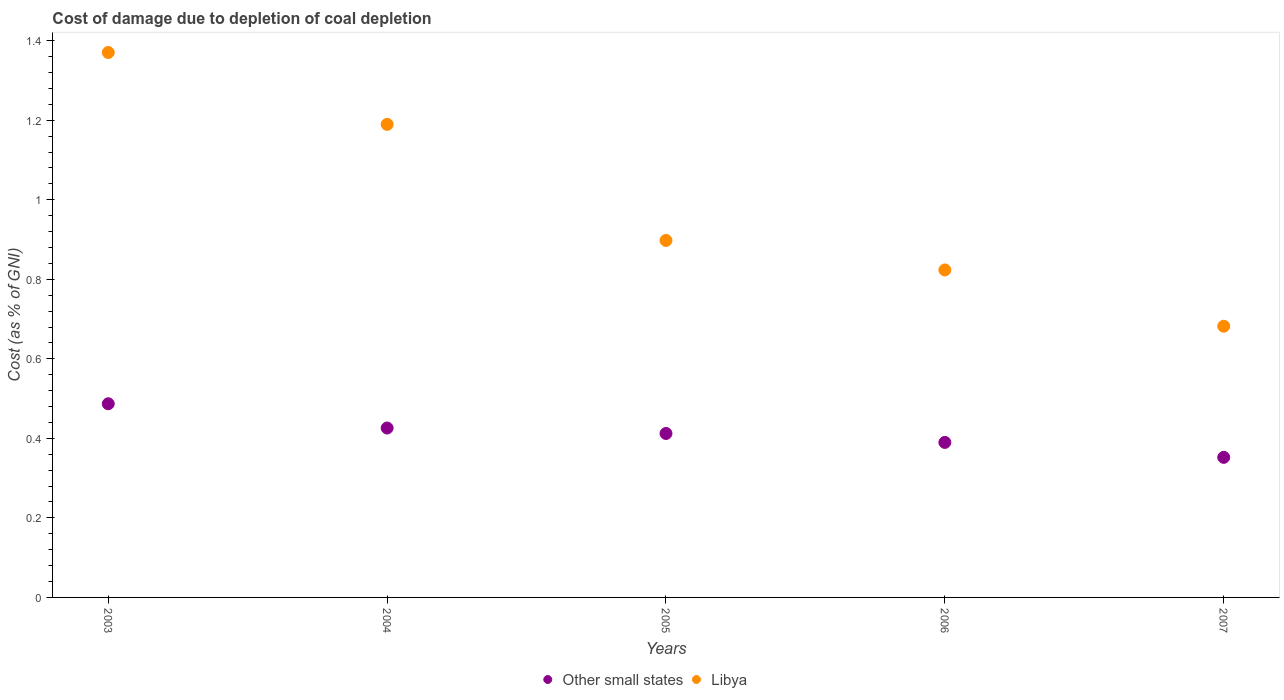How many different coloured dotlines are there?
Your answer should be very brief. 2. What is the cost of damage caused due to coal depletion in Other small states in 2005?
Give a very brief answer. 0.41. Across all years, what is the maximum cost of damage caused due to coal depletion in Libya?
Offer a very short reply. 1.37. Across all years, what is the minimum cost of damage caused due to coal depletion in Other small states?
Keep it short and to the point. 0.35. In which year was the cost of damage caused due to coal depletion in Other small states minimum?
Your answer should be very brief. 2007. What is the total cost of damage caused due to coal depletion in Other small states in the graph?
Offer a very short reply. 2.07. What is the difference between the cost of damage caused due to coal depletion in Other small states in 2006 and that in 2007?
Your answer should be compact. 0.04. What is the difference between the cost of damage caused due to coal depletion in Libya in 2005 and the cost of damage caused due to coal depletion in Other small states in 2007?
Offer a terse response. 0.55. What is the average cost of damage caused due to coal depletion in Other small states per year?
Your answer should be very brief. 0.41. In the year 2007, what is the difference between the cost of damage caused due to coal depletion in Libya and cost of damage caused due to coal depletion in Other small states?
Keep it short and to the point. 0.33. What is the ratio of the cost of damage caused due to coal depletion in Libya in 2003 to that in 2006?
Ensure brevity in your answer.  1.66. Is the cost of damage caused due to coal depletion in Libya in 2005 less than that in 2007?
Provide a succinct answer. No. What is the difference between the highest and the second highest cost of damage caused due to coal depletion in Libya?
Keep it short and to the point. 0.18. What is the difference between the highest and the lowest cost of damage caused due to coal depletion in Other small states?
Ensure brevity in your answer.  0.13. In how many years, is the cost of damage caused due to coal depletion in Libya greater than the average cost of damage caused due to coal depletion in Libya taken over all years?
Your answer should be very brief. 2. Is the sum of the cost of damage caused due to coal depletion in Other small states in 2004 and 2007 greater than the maximum cost of damage caused due to coal depletion in Libya across all years?
Make the answer very short. No. Does the cost of damage caused due to coal depletion in Other small states monotonically increase over the years?
Keep it short and to the point. No. Is the cost of damage caused due to coal depletion in Other small states strictly greater than the cost of damage caused due to coal depletion in Libya over the years?
Offer a terse response. No. Does the graph contain grids?
Ensure brevity in your answer.  No. Where does the legend appear in the graph?
Ensure brevity in your answer.  Bottom center. How many legend labels are there?
Your answer should be very brief. 2. What is the title of the graph?
Make the answer very short. Cost of damage due to depletion of coal depletion. What is the label or title of the Y-axis?
Provide a succinct answer. Cost (as % of GNI). What is the Cost (as % of GNI) of Other small states in 2003?
Your answer should be compact. 0.49. What is the Cost (as % of GNI) of Libya in 2003?
Provide a succinct answer. 1.37. What is the Cost (as % of GNI) in Other small states in 2004?
Ensure brevity in your answer.  0.43. What is the Cost (as % of GNI) of Libya in 2004?
Your answer should be very brief. 1.19. What is the Cost (as % of GNI) of Other small states in 2005?
Ensure brevity in your answer.  0.41. What is the Cost (as % of GNI) of Libya in 2005?
Give a very brief answer. 0.9. What is the Cost (as % of GNI) of Other small states in 2006?
Give a very brief answer. 0.39. What is the Cost (as % of GNI) in Libya in 2006?
Offer a very short reply. 0.82. What is the Cost (as % of GNI) of Other small states in 2007?
Ensure brevity in your answer.  0.35. What is the Cost (as % of GNI) in Libya in 2007?
Make the answer very short. 0.68. Across all years, what is the maximum Cost (as % of GNI) of Other small states?
Provide a succinct answer. 0.49. Across all years, what is the maximum Cost (as % of GNI) of Libya?
Provide a short and direct response. 1.37. Across all years, what is the minimum Cost (as % of GNI) of Other small states?
Make the answer very short. 0.35. Across all years, what is the minimum Cost (as % of GNI) of Libya?
Your response must be concise. 0.68. What is the total Cost (as % of GNI) of Other small states in the graph?
Make the answer very short. 2.07. What is the total Cost (as % of GNI) of Libya in the graph?
Provide a short and direct response. 4.96. What is the difference between the Cost (as % of GNI) in Other small states in 2003 and that in 2004?
Your answer should be very brief. 0.06. What is the difference between the Cost (as % of GNI) of Libya in 2003 and that in 2004?
Offer a very short reply. 0.18. What is the difference between the Cost (as % of GNI) in Other small states in 2003 and that in 2005?
Offer a very short reply. 0.07. What is the difference between the Cost (as % of GNI) in Libya in 2003 and that in 2005?
Give a very brief answer. 0.47. What is the difference between the Cost (as % of GNI) in Other small states in 2003 and that in 2006?
Give a very brief answer. 0.1. What is the difference between the Cost (as % of GNI) of Libya in 2003 and that in 2006?
Ensure brevity in your answer.  0.55. What is the difference between the Cost (as % of GNI) of Other small states in 2003 and that in 2007?
Offer a very short reply. 0.13. What is the difference between the Cost (as % of GNI) in Libya in 2003 and that in 2007?
Make the answer very short. 0.69. What is the difference between the Cost (as % of GNI) in Other small states in 2004 and that in 2005?
Provide a succinct answer. 0.01. What is the difference between the Cost (as % of GNI) in Libya in 2004 and that in 2005?
Your answer should be compact. 0.29. What is the difference between the Cost (as % of GNI) in Other small states in 2004 and that in 2006?
Ensure brevity in your answer.  0.04. What is the difference between the Cost (as % of GNI) in Libya in 2004 and that in 2006?
Make the answer very short. 0.37. What is the difference between the Cost (as % of GNI) in Other small states in 2004 and that in 2007?
Offer a very short reply. 0.07. What is the difference between the Cost (as % of GNI) of Libya in 2004 and that in 2007?
Give a very brief answer. 0.51. What is the difference between the Cost (as % of GNI) of Other small states in 2005 and that in 2006?
Give a very brief answer. 0.02. What is the difference between the Cost (as % of GNI) in Libya in 2005 and that in 2006?
Keep it short and to the point. 0.07. What is the difference between the Cost (as % of GNI) in Libya in 2005 and that in 2007?
Give a very brief answer. 0.22. What is the difference between the Cost (as % of GNI) in Other small states in 2006 and that in 2007?
Offer a terse response. 0.04. What is the difference between the Cost (as % of GNI) in Libya in 2006 and that in 2007?
Give a very brief answer. 0.14. What is the difference between the Cost (as % of GNI) of Other small states in 2003 and the Cost (as % of GNI) of Libya in 2004?
Provide a short and direct response. -0.7. What is the difference between the Cost (as % of GNI) of Other small states in 2003 and the Cost (as % of GNI) of Libya in 2005?
Offer a very short reply. -0.41. What is the difference between the Cost (as % of GNI) in Other small states in 2003 and the Cost (as % of GNI) in Libya in 2006?
Your response must be concise. -0.34. What is the difference between the Cost (as % of GNI) in Other small states in 2003 and the Cost (as % of GNI) in Libya in 2007?
Keep it short and to the point. -0.2. What is the difference between the Cost (as % of GNI) of Other small states in 2004 and the Cost (as % of GNI) of Libya in 2005?
Make the answer very short. -0.47. What is the difference between the Cost (as % of GNI) of Other small states in 2004 and the Cost (as % of GNI) of Libya in 2006?
Your response must be concise. -0.4. What is the difference between the Cost (as % of GNI) of Other small states in 2004 and the Cost (as % of GNI) of Libya in 2007?
Provide a succinct answer. -0.26. What is the difference between the Cost (as % of GNI) in Other small states in 2005 and the Cost (as % of GNI) in Libya in 2006?
Your answer should be very brief. -0.41. What is the difference between the Cost (as % of GNI) of Other small states in 2005 and the Cost (as % of GNI) of Libya in 2007?
Your answer should be very brief. -0.27. What is the difference between the Cost (as % of GNI) in Other small states in 2006 and the Cost (as % of GNI) in Libya in 2007?
Make the answer very short. -0.29. What is the average Cost (as % of GNI) in Other small states per year?
Your answer should be compact. 0.41. In the year 2003, what is the difference between the Cost (as % of GNI) of Other small states and Cost (as % of GNI) of Libya?
Your answer should be compact. -0.88. In the year 2004, what is the difference between the Cost (as % of GNI) of Other small states and Cost (as % of GNI) of Libya?
Give a very brief answer. -0.76. In the year 2005, what is the difference between the Cost (as % of GNI) of Other small states and Cost (as % of GNI) of Libya?
Provide a short and direct response. -0.49. In the year 2006, what is the difference between the Cost (as % of GNI) of Other small states and Cost (as % of GNI) of Libya?
Make the answer very short. -0.43. In the year 2007, what is the difference between the Cost (as % of GNI) in Other small states and Cost (as % of GNI) in Libya?
Give a very brief answer. -0.33. What is the ratio of the Cost (as % of GNI) of Other small states in 2003 to that in 2004?
Your answer should be compact. 1.14. What is the ratio of the Cost (as % of GNI) of Libya in 2003 to that in 2004?
Give a very brief answer. 1.15. What is the ratio of the Cost (as % of GNI) of Other small states in 2003 to that in 2005?
Make the answer very short. 1.18. What is the ratio of the Cost (as % of GNI) of Libya in 2003 to that in 2005?
Your answer should be very brief. 1.53. What is the ratio of the Cost (as % of GNI) in Other small states in 2003 to that in 2006?
Your response must be concise. 1.25. What is the ratio of the Cost (as % of GNI) in Libya in 2003 to that in 2006?
Your answer should be very brief. 1.66. What is the ratio of the Cost (as % of GNI) in Other small states in 2003 to that in 2007?
Your response must be concise. 1.38. What is the ratio of the Cost (as % of GNI) in Libya in 2003 to that in 2007?
Your answer should be very brief. 2.01. What is the ratio of the Cost (as % of GNI) of Other small states in 2004 to that in 2005?
Offer a very short reply. 1.03. What is the ratio of the Cost (as % of GNI) of Libya in 2004 to that in 2005?
Give a very brief answer. 1.33. What is the ratio of the Cost (as % of GNI) of Other small states in 2004 to that in 2006?
Your answer should be very brief. 1.09. What is the ratio of the Cost (as % of GNI) in Libya in 2004 to that in 2006?
Provide a short and direct response. 1.44. What is the ratio of the Cost (as % of GNI) in Other small states in 2004 to that in 2007?
Make the answer very short. 1.21. What is the ratio of the Cost (as % of GNI) in Libya in 2004 to that in 2007?
Provide a short and direct response. 1.74. What is the ratio of the Cost (as % of GNI) in Other small states in 2005 to that in 2006?
Make the answer very short. 1.06. What is the ratio of the Cost (as % of GNI) of Libya in 2005 to that in 2006?
Make the answer very short. 1.09. What is the ratio of the Cost (as % of GNI) in Other small states in 2005 to that in 2007?
Keep it short and to the point. 1.17. What is the ratio of the Cost (as % of GNI) of Libya in 2005 to that in 2007?
Ensure brevity in your answer.  1.32. What is the ratio of the Cost (as % of GNI) in Other small states in 2006 to that in 2007?
Offer a terse response. 1.11. What is the ratio of the Cost (as % of GNI) in Libya in 2006 to that in 2007?
Keep it short and to the point. 1.21. What is the difference between the highest and the second highest Cost (as % of GNI) of Other small states?
Ensure brevity in your answer.  0.06. What is the difference between the highest and the second highest Cost (as % of GNI) in Libya?
Give a very brief answer. 0.18. What is the difference between the highest and the lowest Cost (as % of GNI) in Other small states?
Your response must be concise. 0.13. What is the difference between the highest and the lowest Cost (as % of GNI) of Libya?
Ensure brevity in your answer.  0.69. 